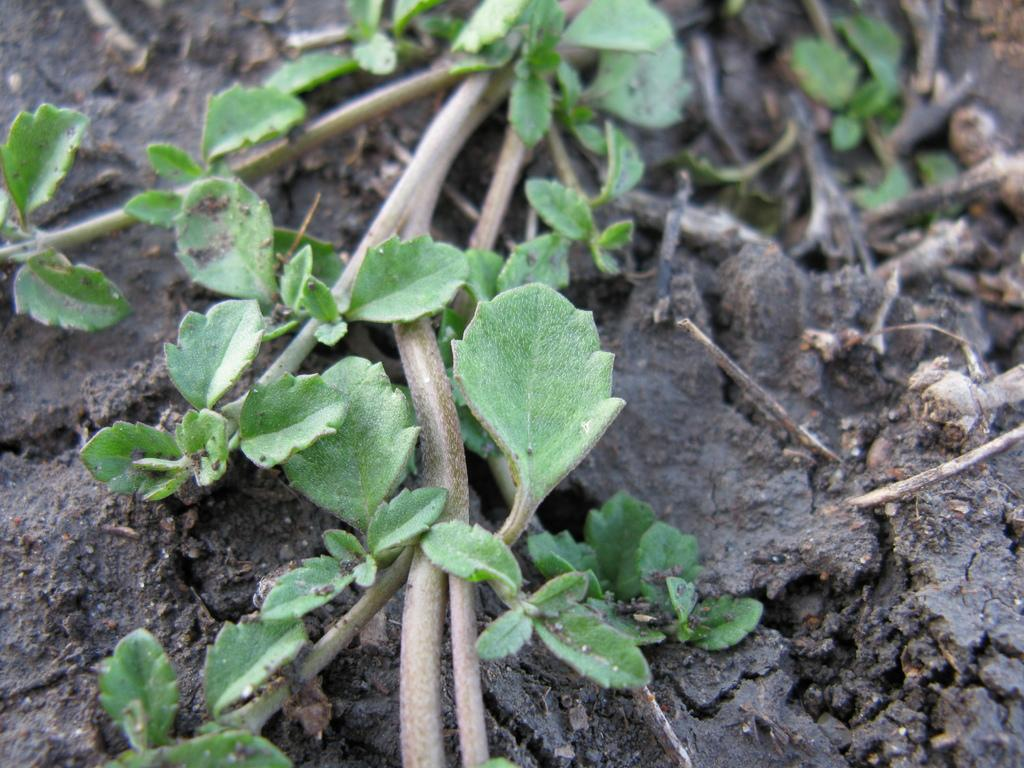What type of vegetation can be seen on the surface of the dried soil? There are leaves and stems on the surface of the dried soil. What is the condition of the soil in the image? The soil appears to be dried. What type of needle can be seen piercing the leaves in the image? There is no needle present in the image; only leaves and stems on dried soil are visible. 